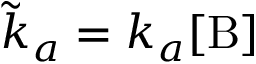<formula> <loc_0><loc_0><loc_500><loc_500>\tilde { k } _ { a } = k _ { a } [ B ]</formula> 